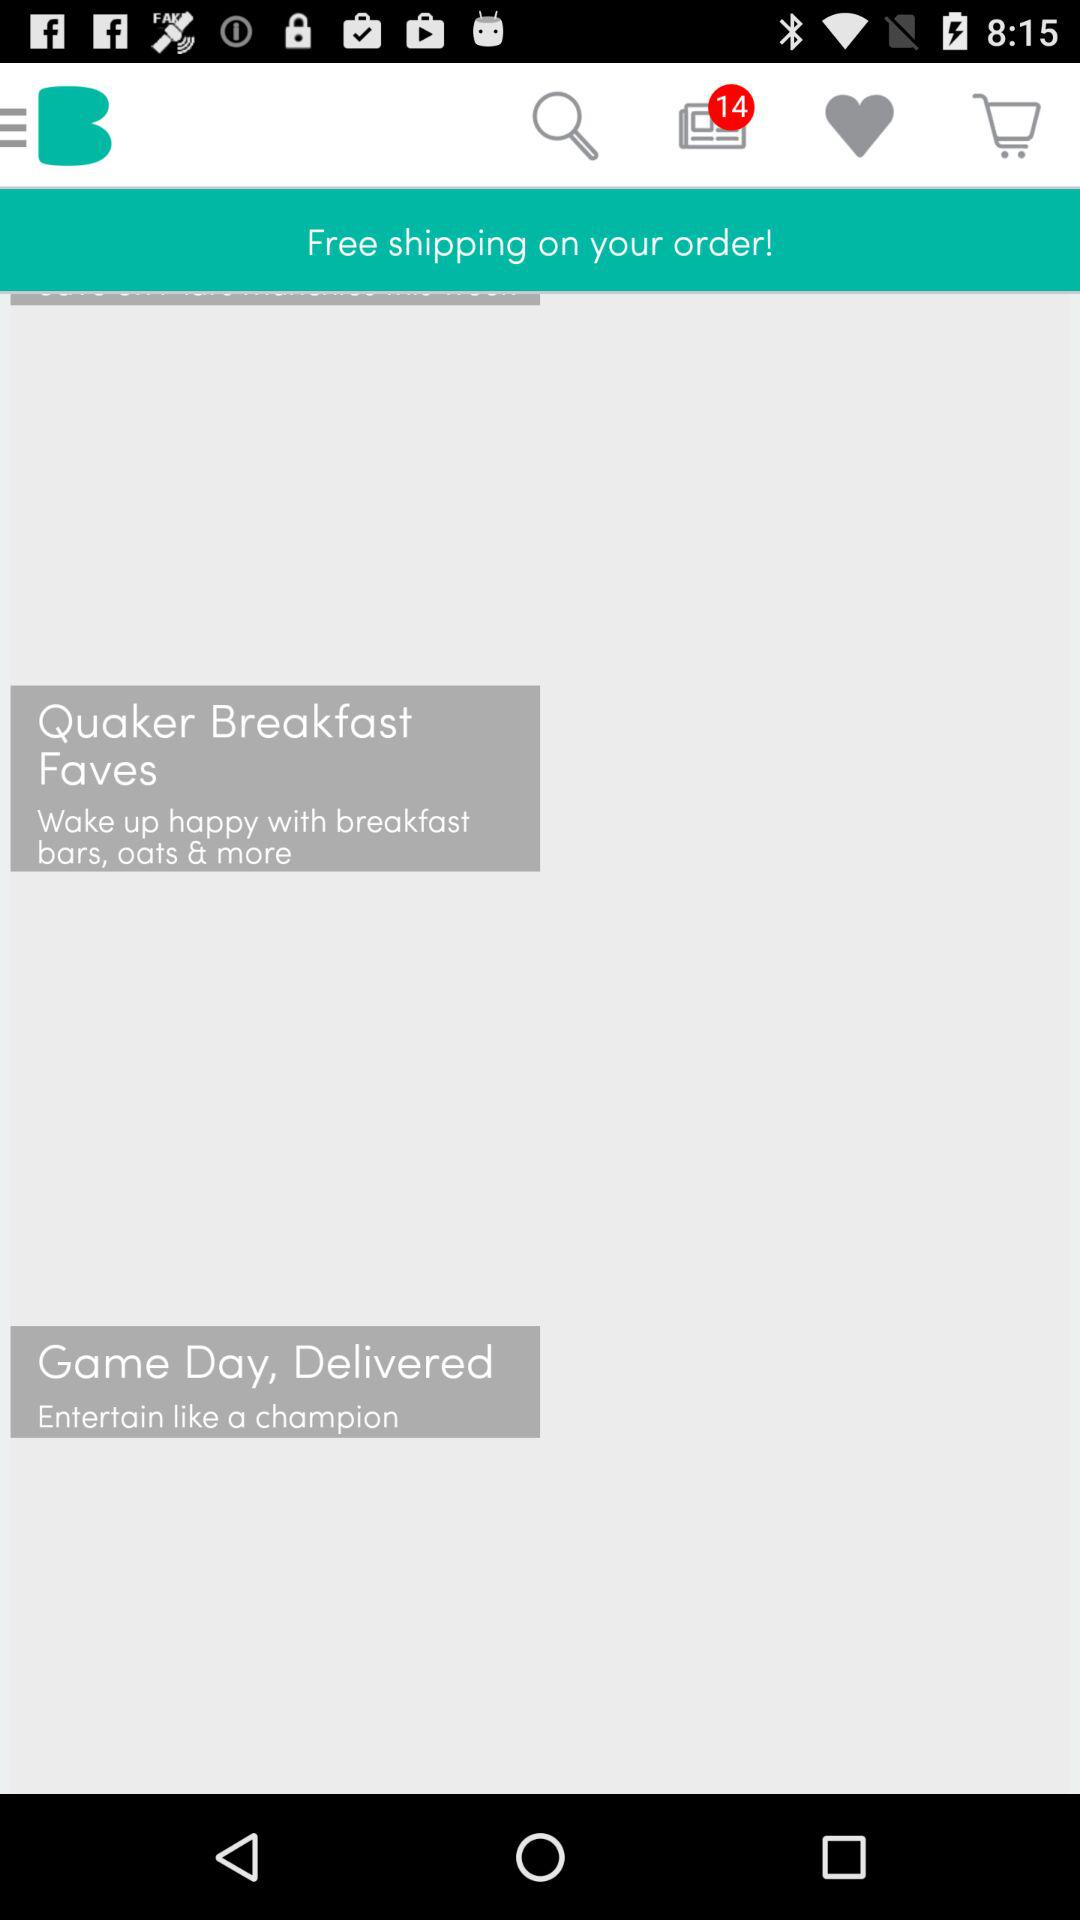What is the status of Game Day?
When the provided information is insufficient, respond with <no answer>. <no answer> 